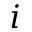<formula> <loc_0><loc_0><loc_500><loc_500>i</formula> 